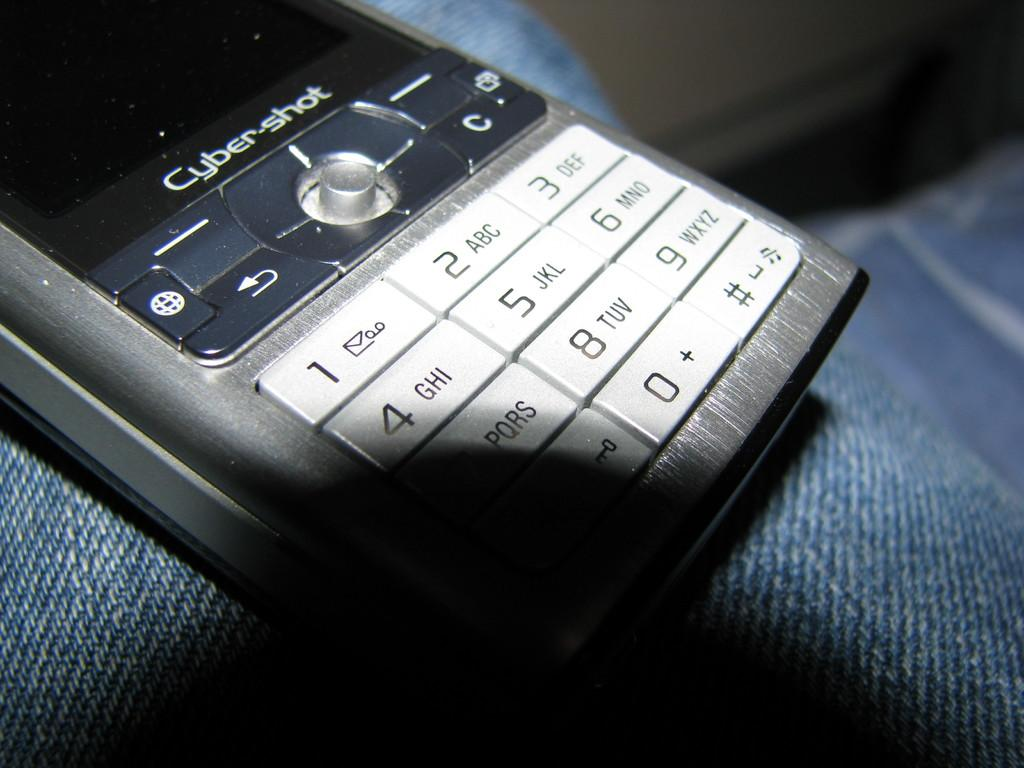<image>
Offer a succinct explanation of the picture presented. The numbers 1 2 and 3 are shown on an old Cyber Shot phone 